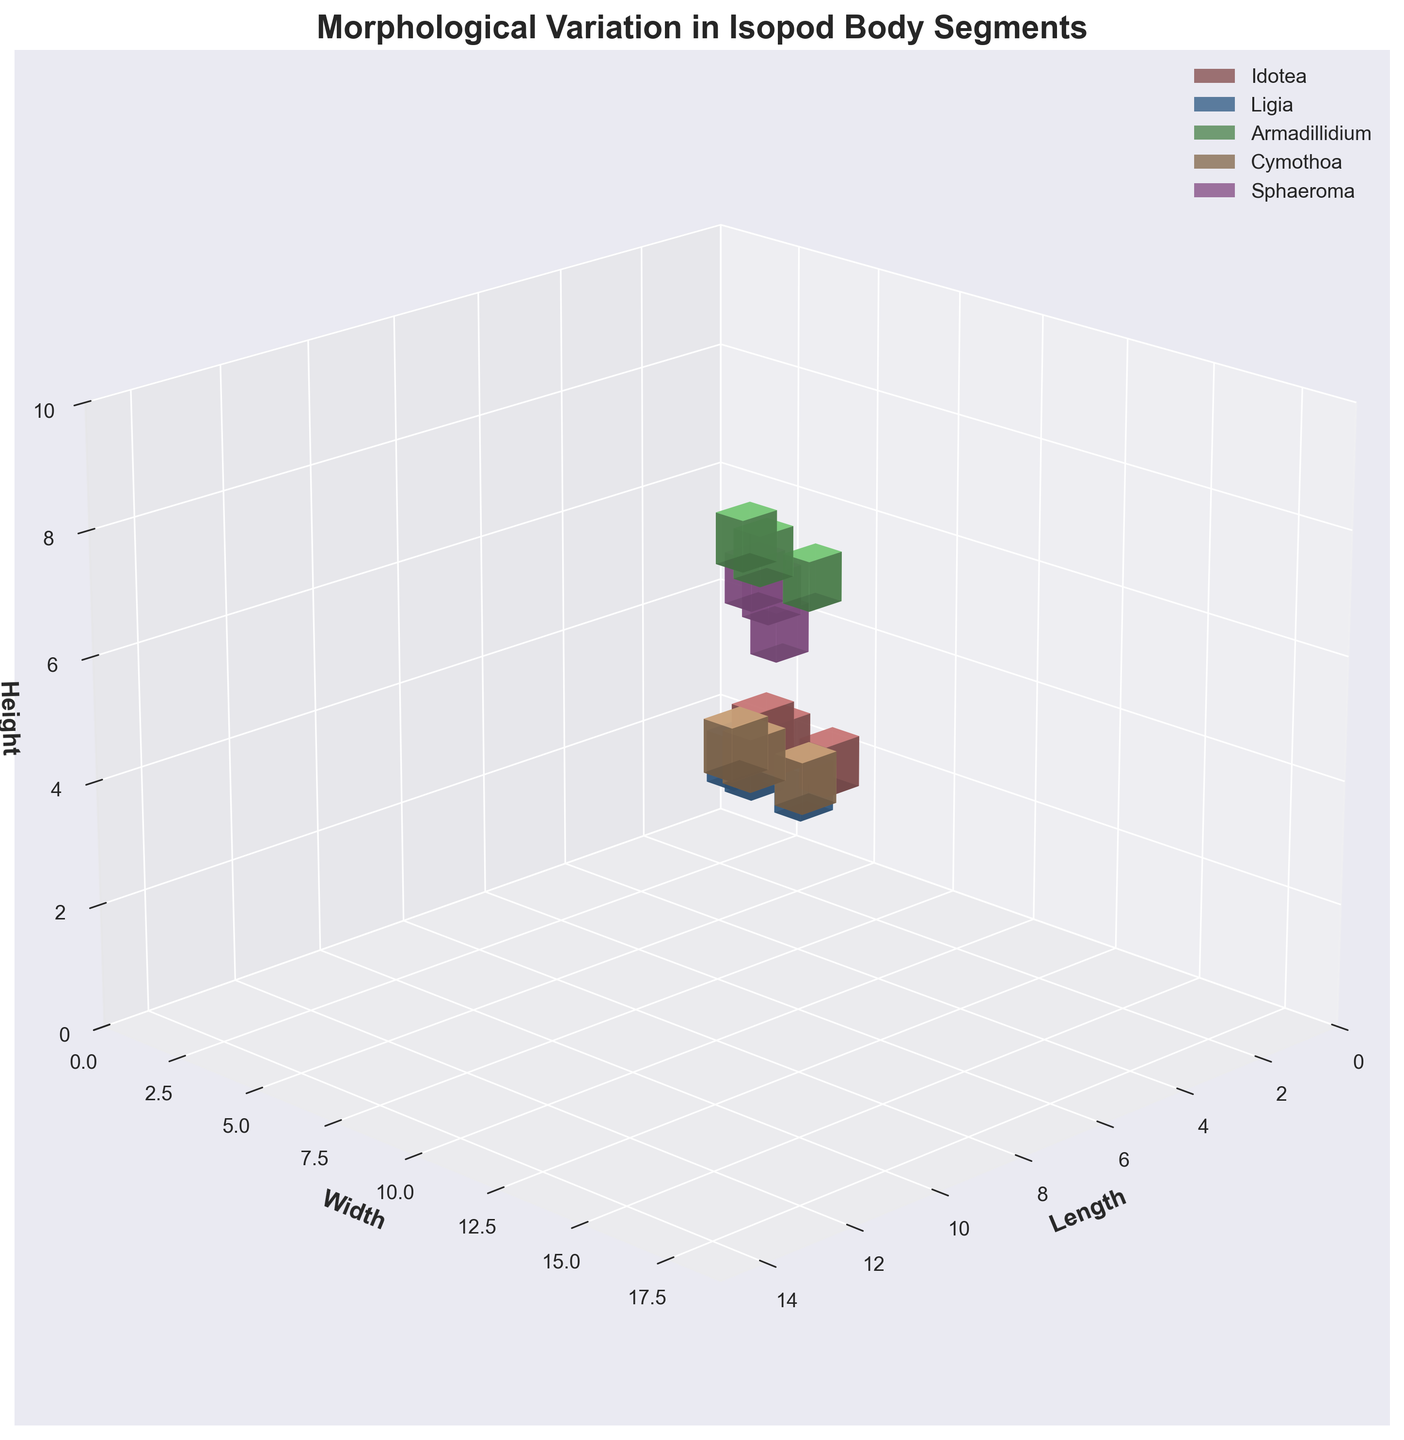What is the genus with the highest width on Pereonite 7? Looking at the 3D voxel structures, identify the genus with the highest value on the Width (Y-axis) corresponding to Pereonite 7. Cymothoa has the highest width value of 17.
Answer: Cymothoa How many genera have a Pleonite with a height of 5? Identify bars in the 3D plot that correspond to Pleonite segments with a Height (Z-axis) value of 5. Both Idotea and Cymothoa show a Pleonite height of 5.
Answer: 2 Which genus has the shortest length on Pereonite 1? Examine the 3D voxel structures for Pereonite 1 and find the genus with the smallest Length (X-axis) value. Sphaeroma has the shortest length on Pereonite 1 with a value of 5.
Answer: Sphaeroma What is the average Height of the Pleonite segment across all genera? Identify the height values of the Pleonite across all genera and compute their mean. Heights are 4, 3, 6, 5, 5, so the average is (4+3+6+5+5)/5 = 4.6.
Answer: 4.6 Compare the Width of Pereonite 7 between Idotea and Armadillidium— which genus has the greater Width? Compare the Width values (Y-axis) for Pereonite 7 between Idotea (14) and Armadillidium (11). Idotea has a greater width.
Answer: Idotea What is the total Length of all Pereonite 7 segments? Sum the Length values (X-axis) of Pereonite 7 for all genera. Lengths are 10 (Idotea), 9 (Ligia), 8 (Armadillidium), 13 (Cymothoa), 7 (Sphaeroma). Total is 10+9+8+13+7=47.
Answer: 47 Which genus shows the greatest morphological variation in Pereonite 1's Width and Height? Identify the maximum difference between Width and Height for Pereonite 1 across all genera. Armadillidium shows a difference of 2 between Width (9) and Height (7).
Answer: Armadillidium Is the height of Pereonite 7 for Ligia greater than the height of Pereonite 7 for Sphaeroma? Compare the height (Z-axis) values of Pereonite 7 for Ligia (5) and Sphaeroma (7). The height for Sphaeroma is greater.
Answer: No What is the sum of the Widths of idotea's Pereonite 1 and Pleonite segments? Sum the Width (Y-axis) values of Pereonite 1 (12) and Pleonite (11) for Idotea. Total is 12+11=23.
Answer: 23 